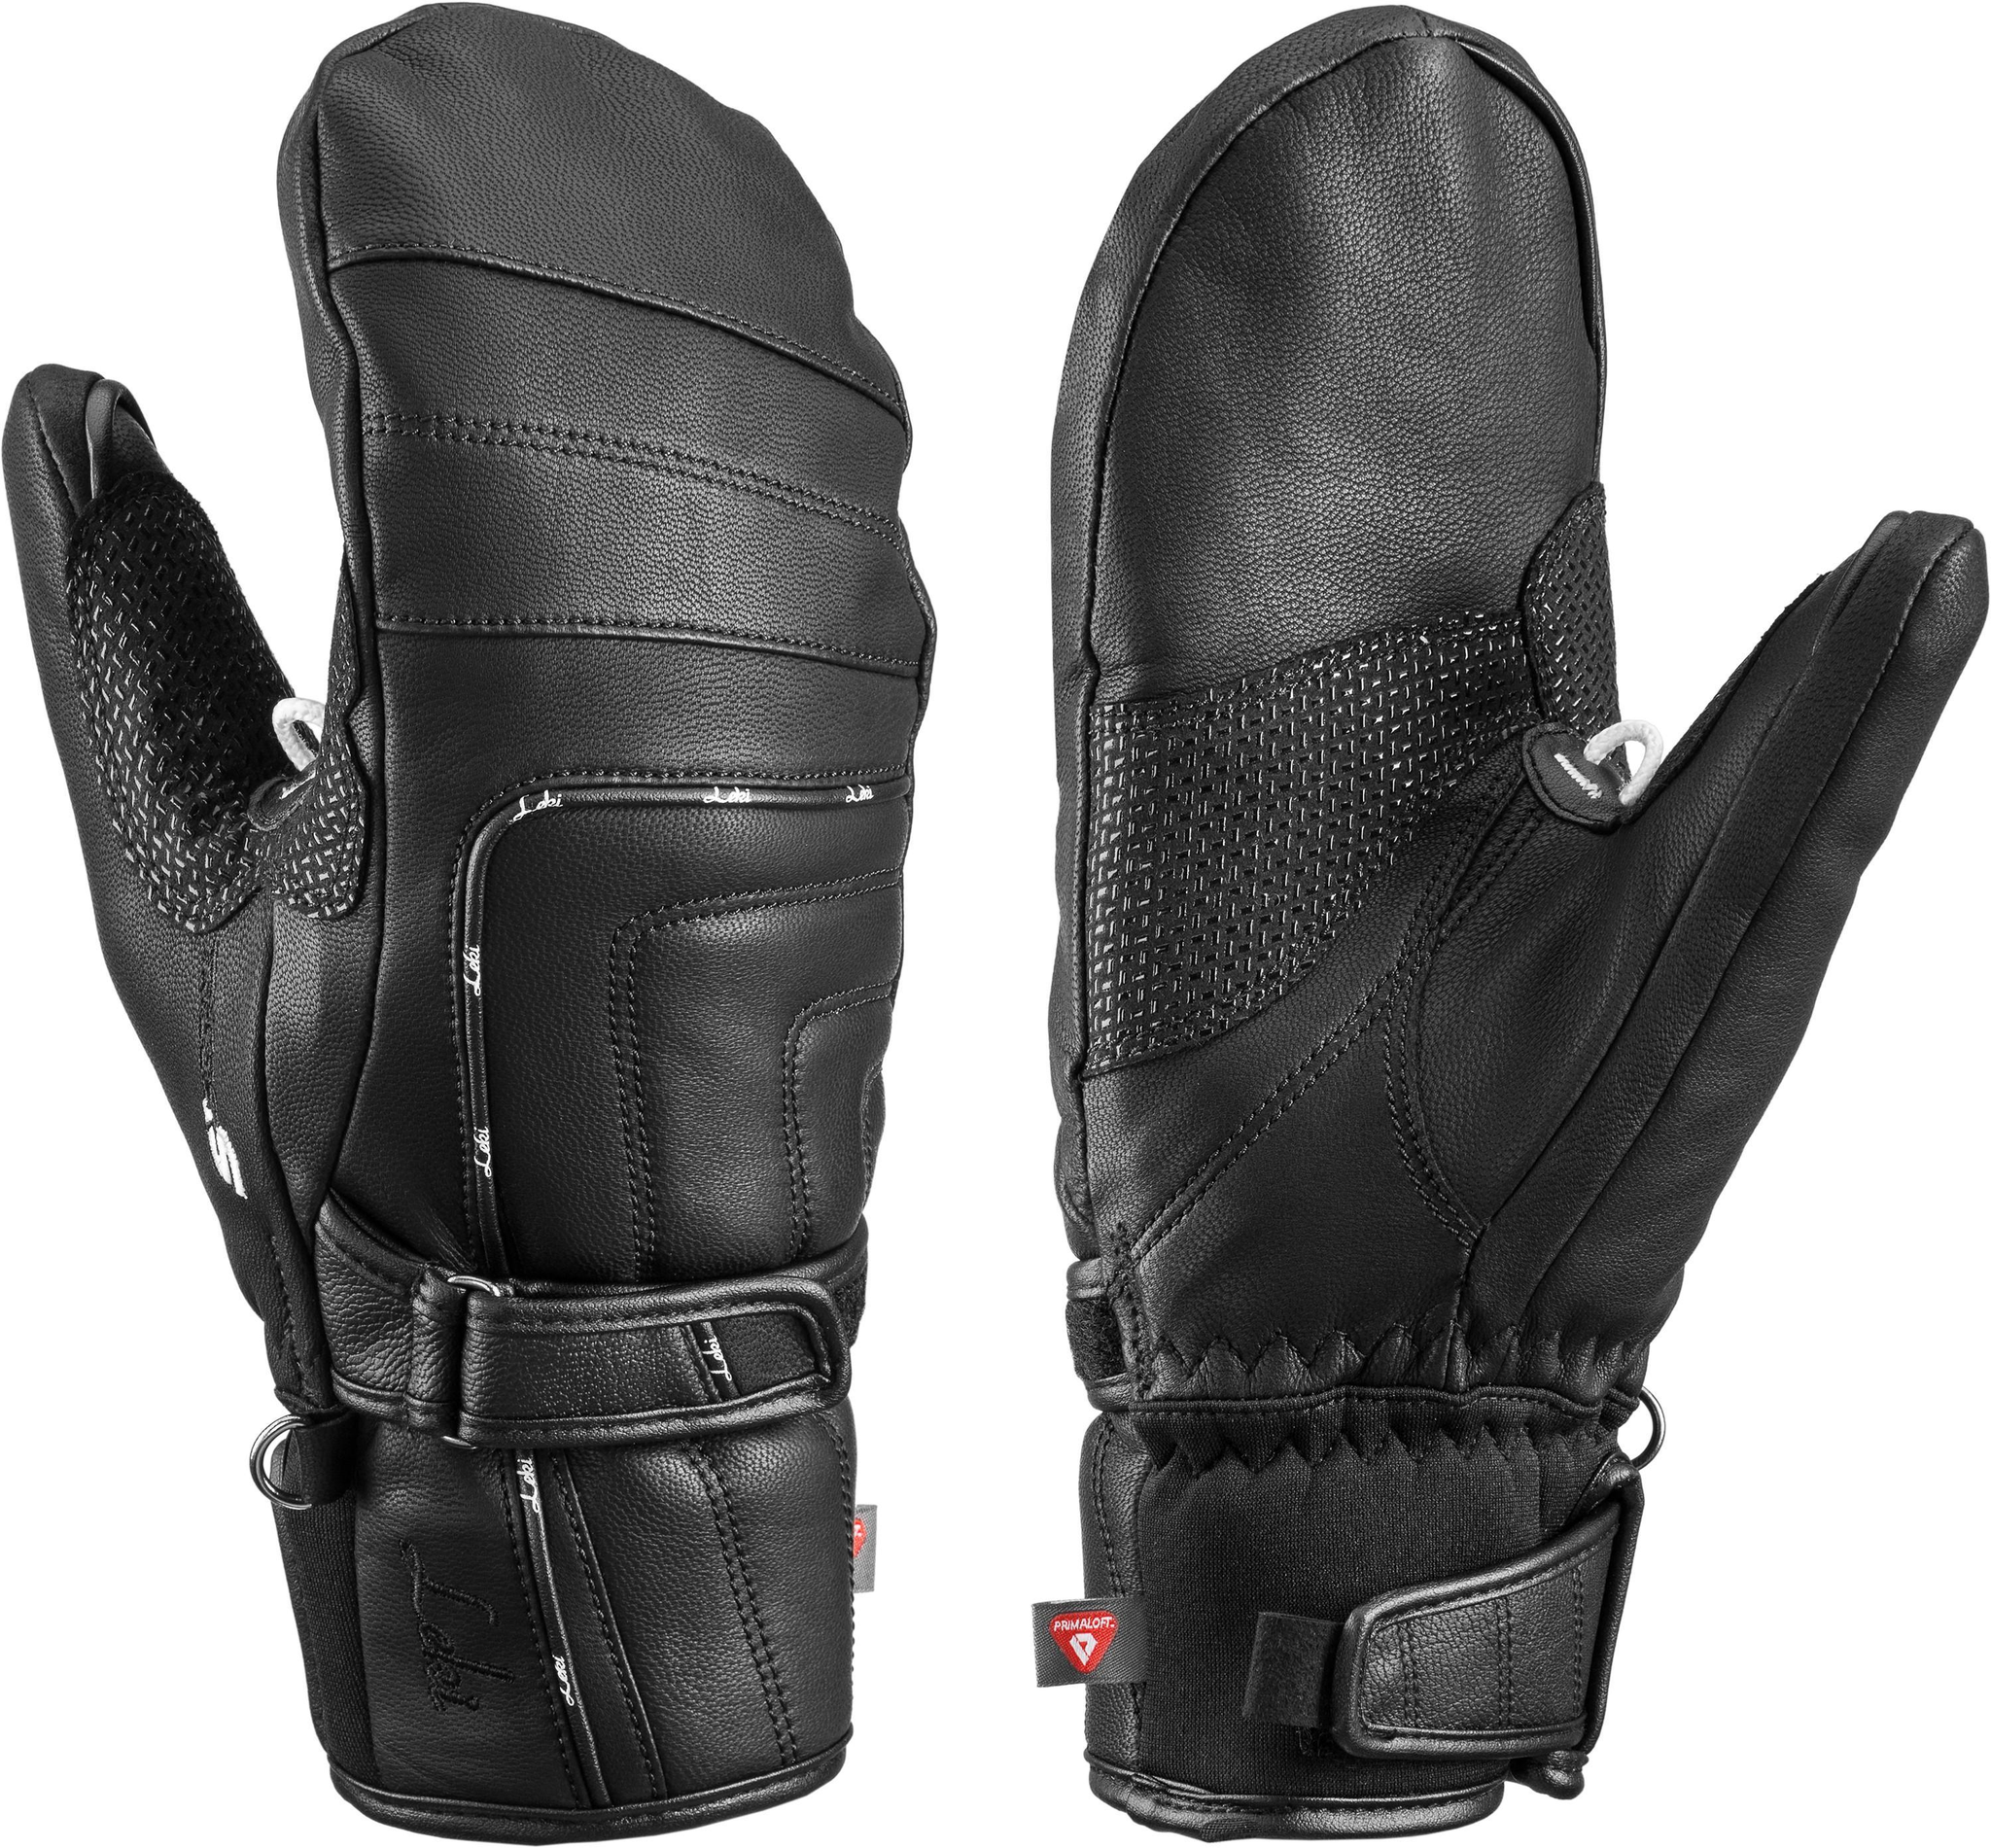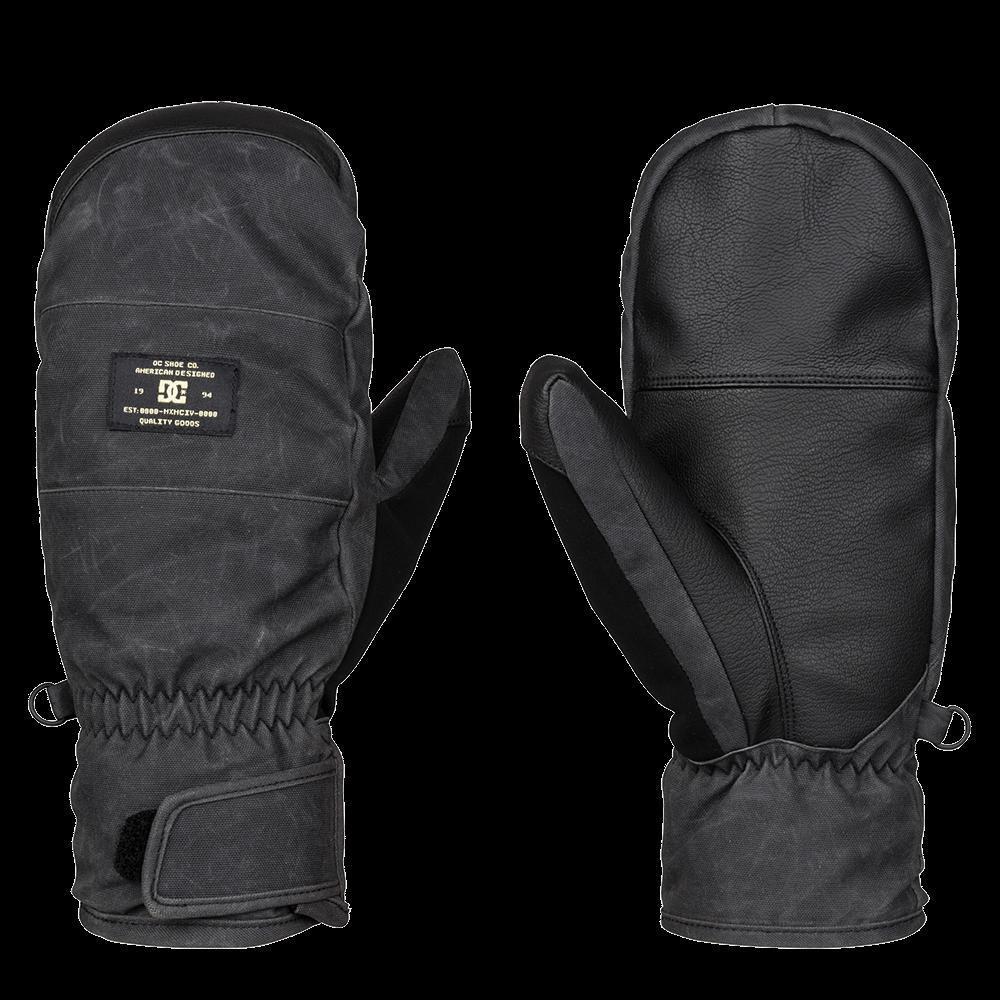The first image is the image on the left, the second image is the image on the right. Examine the images to the left and right. Is the description "Each image shows the front and back of a pair of black mittens with no individual fingers, and no pair of mittens has overlapping individual mittens." accurate? Answer yes or no. Yes. 